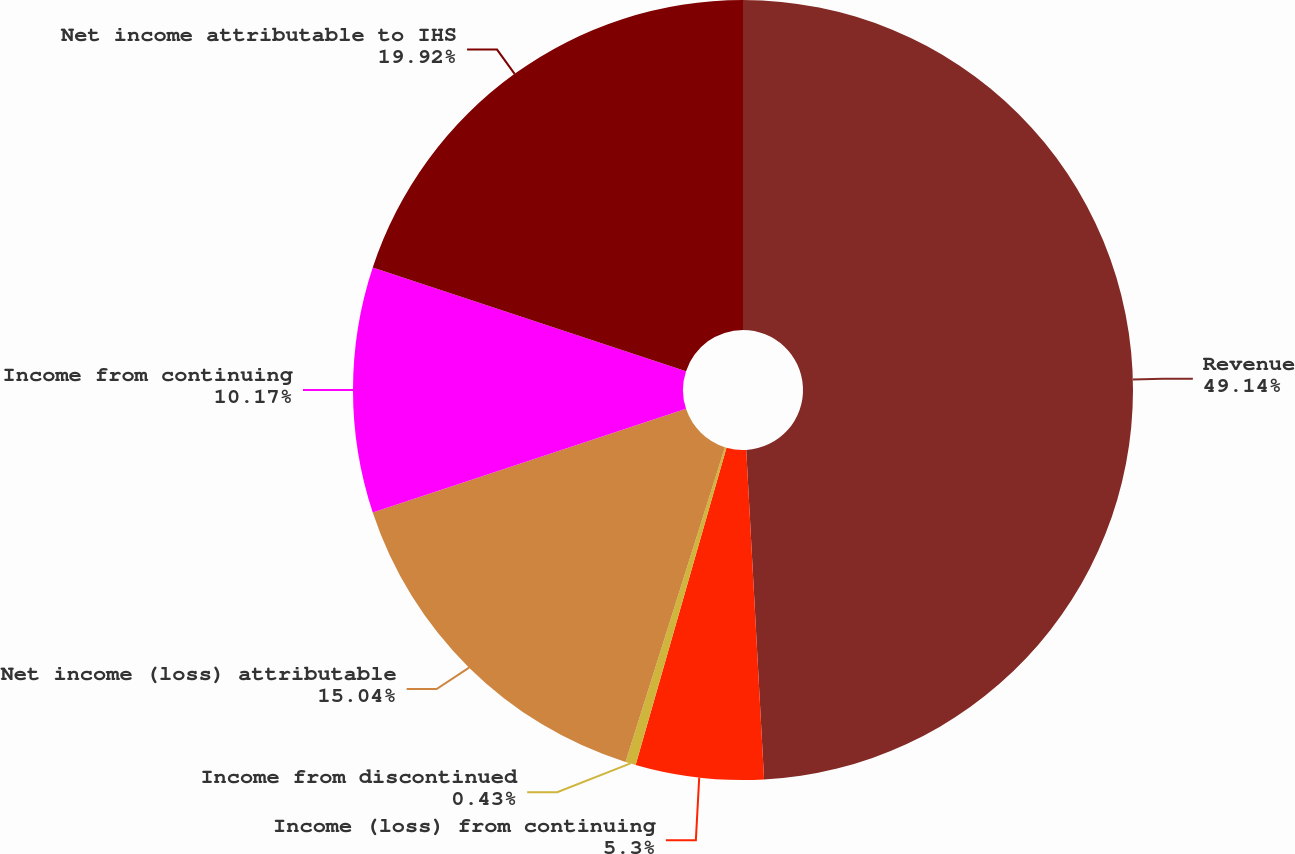Convert chart to OTSL. <chart><loc_0><loc_0><loc_500><loc_500><pie_chart><fcel>Revenue<fcel>Income (loss) from continuing<fcel>Income from discontinued<fcel>Net income (loss) attributable<fcel>Income from continuing<fcel>Net income attributable to IHS<nl><fcel>49.13%<fcel>5.3%<fcel>0.43%<fcel>15.04%<fcel>10.17%<fcel>19.91%<nl></chart> 